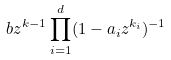Convert formula to latex. <formula><loc_0><loc_0><loc_500><loc_500>b z ^ { k - 1 } \prod _ { i = 1 } ^ { d } ( 1 - a _ { i } z ^ { k _ { i } } ) ^ { - 1 }</formula> 